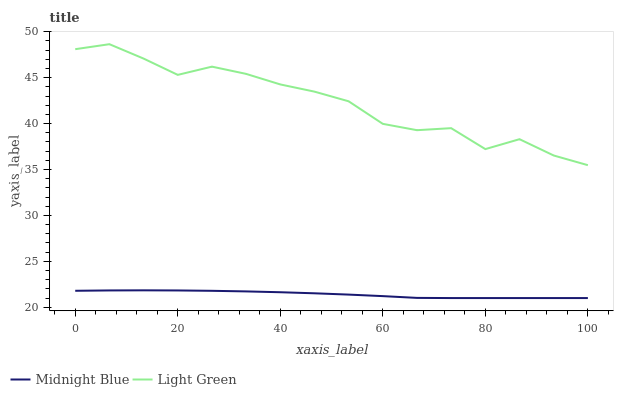Does Midnight Blue have the minimum area under the curve?
Answer yes or no. Yes. Does Light Green have the maximum area under the curve?
Answer yes or no. Yes. Does Light Green have the minimum area under the curve?
Answer yes or no. No. Is Midnight Blue the smoothest?
Answer yes or no. Yes. Is Light Green the roughest?
Answer yes or no. Yes. Is Light Green the smoothest?
Answer yes or no. No. Does Midnight Blue have the lowest value?
Answer yes or no. Yes. Does Light Green have the lowest value?
Answer yes or no. No. Does Light Green have the highest value?
Answer yes or no. Yes. Is Midnight Blue less than Light Green?
Answer yes or no. Yes. Is Light Green greater than Midnight Blue?
Answer yes or no. Yes. Does Midnight Blue intersect Light Green?
Answer yes or no. No. 